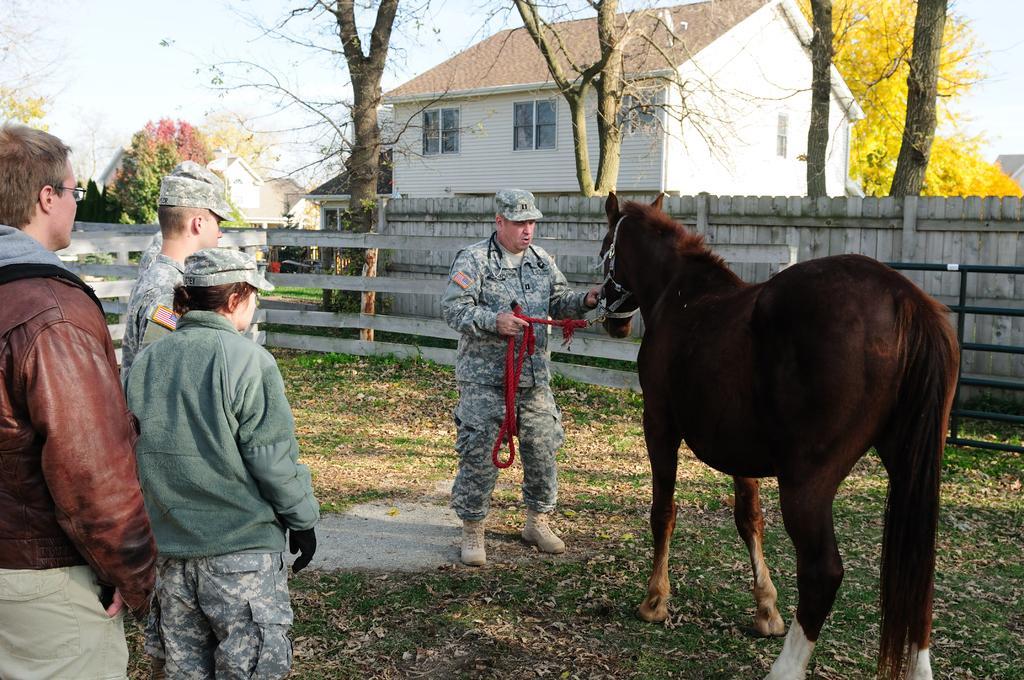Please provide a concise description of this image. This picture is of outside. On the right there is a horse and a man wearing the uniform and standing on the ground. On the left there are group of person standing on the ground. In the background we can see the sky, trees, house. 